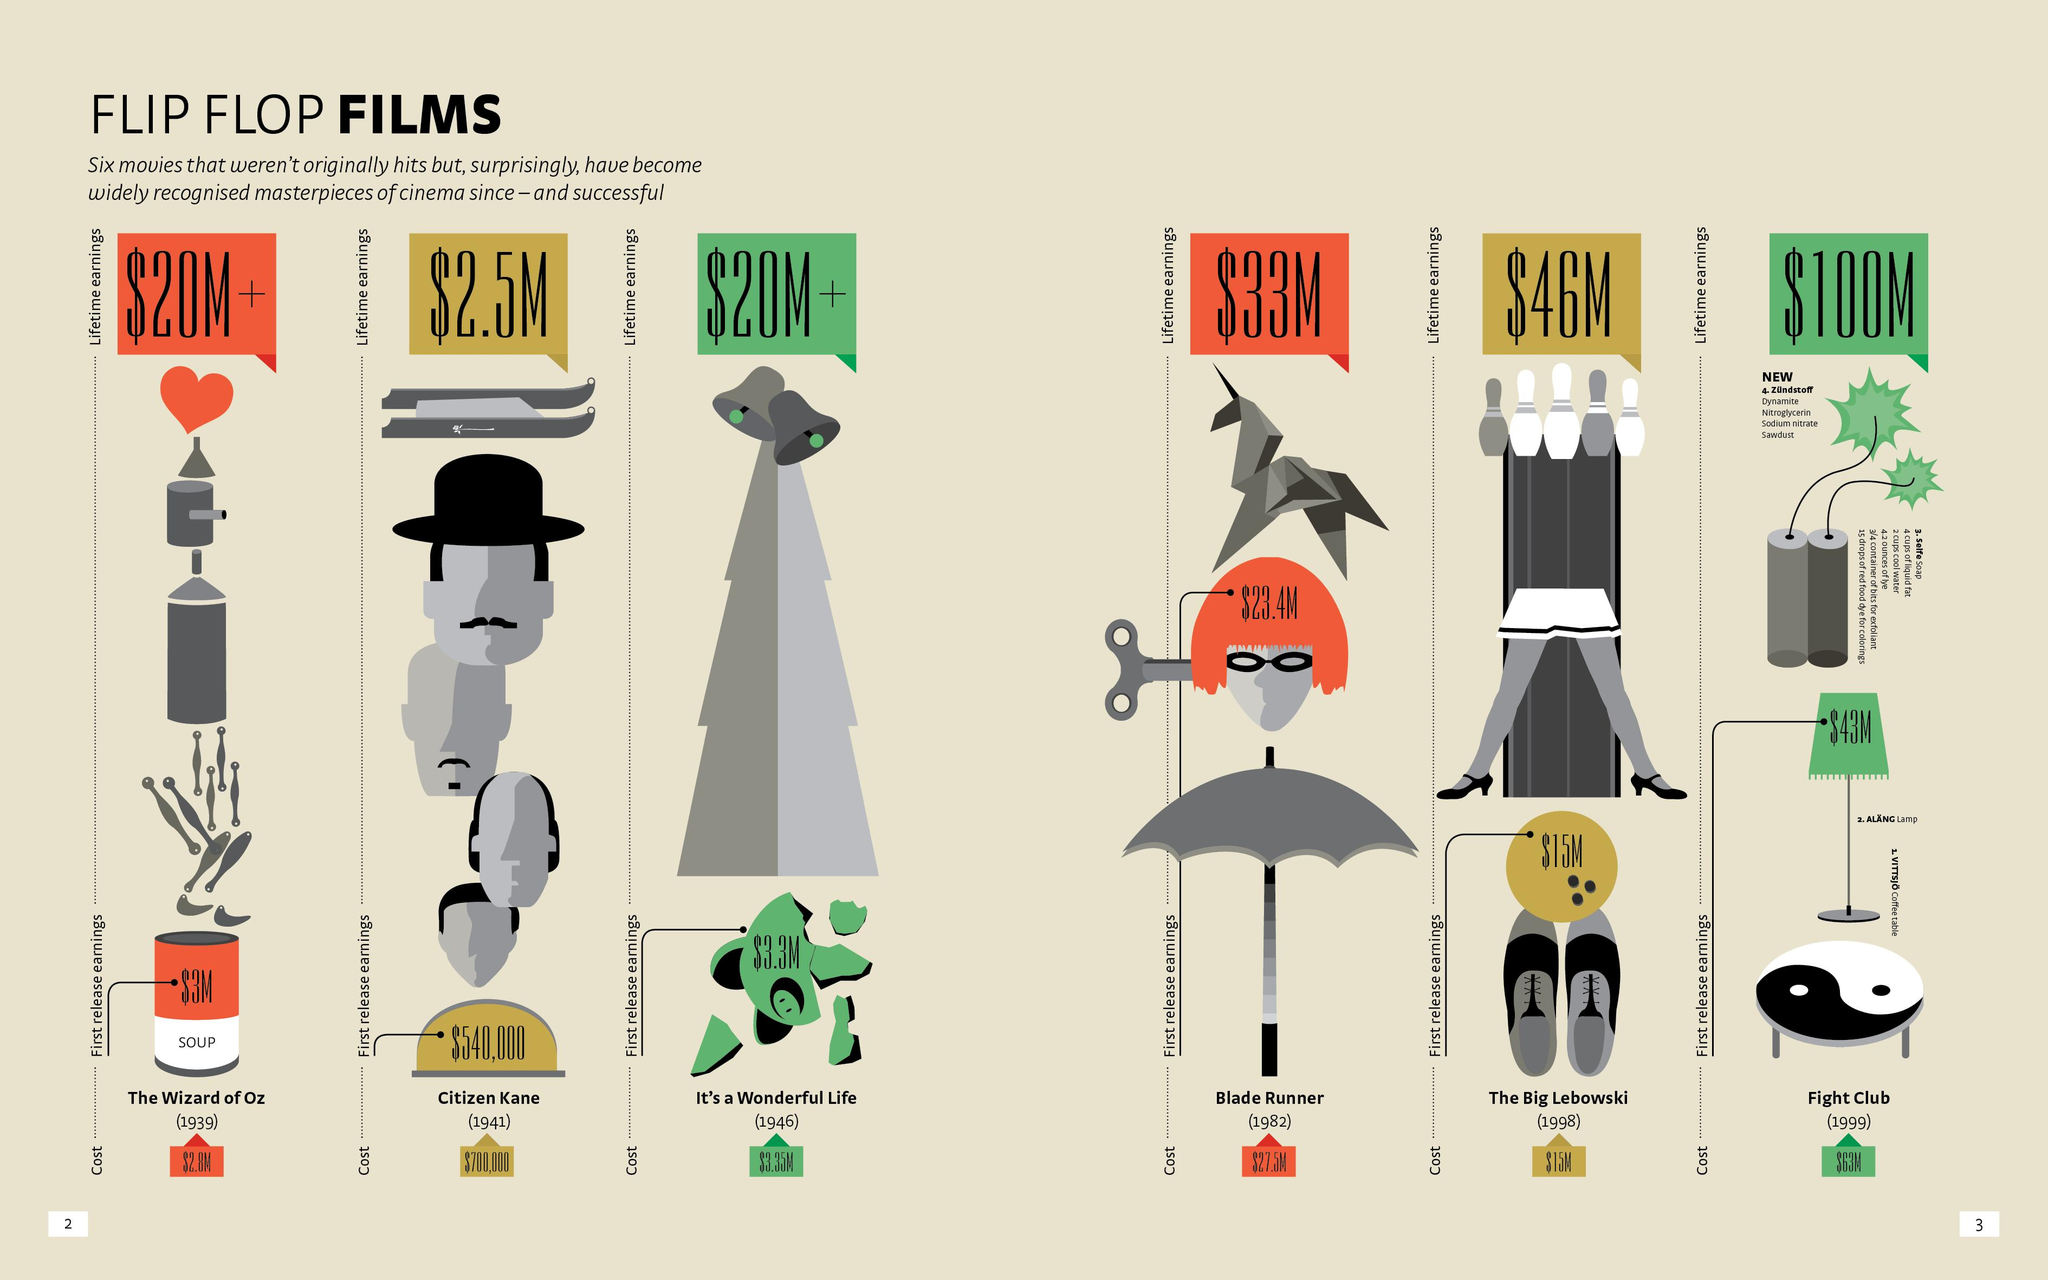Specify some key components in this picture. The initial production cost of the movie that had a lifetime earning of $2.5 million was $3.35 million. The lifetime earnings of the movies "The Wizard of Oz" and "It's a Wonderful Life" were both $20 million or more. The cost of making the masterpiece movie was a mere $700,000, the lowest amount incurred for such a production. The highest movie cost incurred was $63 million. Fight Club is the movie that has earned the highest lifetime earnings. 